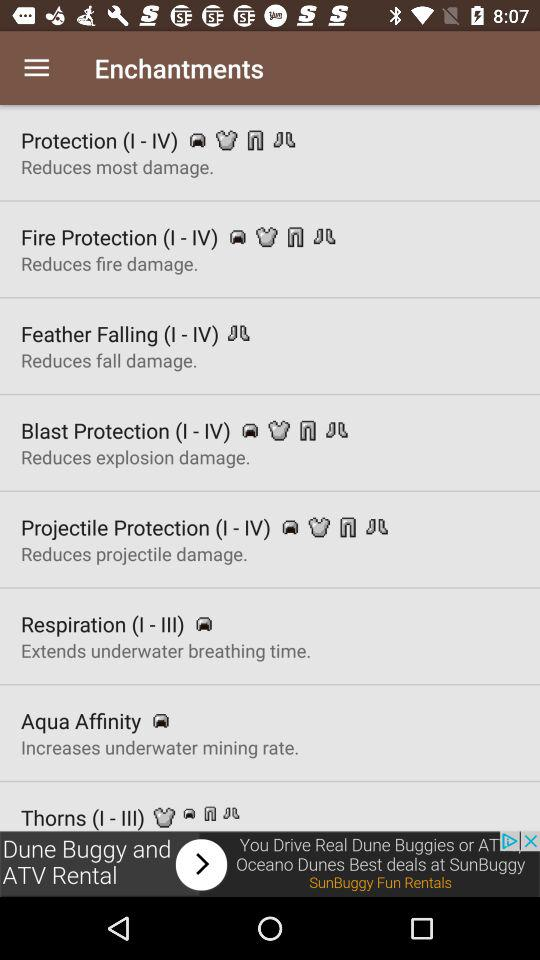What is the use of blast protection? The use of blast protection is to reduce explosion damage. 